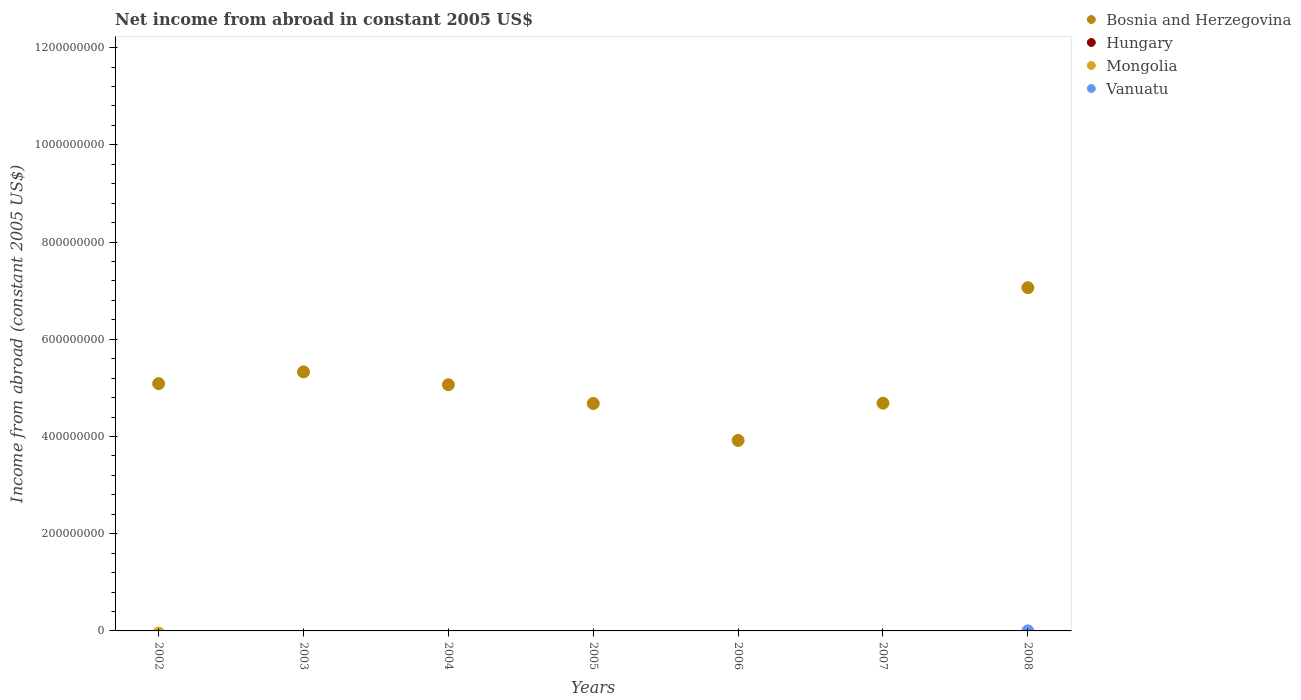How many different coloured dotlines are there?
Your response must be concise. 2. What is the net income from abroad in Mongolia in 2005?
Offer a terse response. 0. Across all years, what is the maximum net income from abroad in Bosnia and Herzegovina?
Offer a very short reply. 7.06e+08. In which year was the net income from abroad in Bosnia and Herzegovina maximum?
Give a very brief answer. 2008. What is the total net income from abroad in Mongolia in the graph?
Keep it short and to the point. 0. What is the difference between the net income from abroad in Bosnia and Herzegovina in 2003 and that in 2006?
Give a very brief answer. 1.41e+08. What is the difference between the net income from abroad in Mongolia in 2002 and the net income from abroad in Bosnia and Herzegovina in 2008?
Your answer should be very brief. -7.06e+08. What is the average net income from abroad in Bosnia and Herzegovina per year?
Keep it short and to the point. 5.12e+08. In how many years, is the net income from abroad in Vanuatu greater than 1040000000 US$?
Provide a succinct answer. 0. What is the ratio of the net income from abroad in Bosnia and Herzegovina in 2005 to that in 2007?
Provide a succinct answer. 1. Is the net income from abroad in Bosnia and Herzegovina in 2004 less than that in 2005?
Give a very brief answer. No. What is the difference between the highest and the second highest net income from abroad in Bosnia and Herzegovina?
Keep it short and to the point. 1.73e+08. What is the difference between the highest and the lowest net income from abroad in Vanuatu?
Your answer should be very brief. 9.87e+04. Is the sum of the net income from abroad in Bosnia and Herzegovina in 2003 and 2005 greater than the maximum net income from abroad in Vanuatu across all years?
Ensure brevity in your answer.  Yes. Is it the case that in every year, the sum of the net income from abroad in Vanuatu and net income from abroad in Bosnia and Herzegovina  is greater than the sum of net income from abroad in Hungary and net income from abroad in Mongolia?
Offer a very short reply. Yes. Is it the case that in every year, the sum of the net income from abroad in Mongolia and net income from abroad in Bosnia and Herzegovina  is greater than the net income from abroad in Vanuatu?
Provide a short and direct response. Yes. Does the net income from abroad in Hungary monotonically increase over the years?
Your response must be concise. No. Is the net income from abroad in Hungary strictly less than the net income from abroad in Vanuatu over the years?
Provide a succinct answer. Yes. What is the difference between two consecutive major ticks on the Y-axis?
Make the answer very short. 2.00e+08. Are the values on the major ticks of Y-axis written in scientific E-notation?
Offer a terse response. No. Does the graph contain any zero values?
Give a very brief answer. Yes. How many legend labels are there?
Your response must be concise. 4. What is the title of the graph?
Offer a very short reply. Net income from abroad in constant 2005 US$. Does "Malta" appear as one of the legend labels in the graph?
Give a very brief answer. No. What is the label or title of the X-axis?
Ensure brevity in your answer.  Years. What is the label or title of the Y-axis?
Provide a short and direct response. Income from abroad (constant 2005 US$). What is the Income from abroad (constant 2005 US$) of Bosnia and Herzegovina in 2002?
Offer a very short reply. 5.09e+08. What is the Income from abroad (constant 2005 US$) of Hungary in 2002?
Your response must be concise. 0. What is the Income from abroad (constant 2005 US$) of Bosnia and Herzegovina in 2003?
Ensure brevity in your answer.  5.33e+08. What is the Income from abroad (constant 2005 US$) in Hungary in 2003?
Your answer should be compact. 0. What is the Income from abroad (constant 2005 US$) of Vanuatu in 2003?
Provide a short and direct response. 0. What is the Income from abroad (constant 2005 US$) in Bosnia and Herzegovina in 2004?
Ensure brevity in your answer.  5.06e+08. What is the Income from abroad (constant 2005 US$) of Bosnia and Herzegovina in 2005?
Your answer should be very brief. 4.68e+08. What is the Income from abroad (constant 2005 US$) in Hungary in 2005?
Your answer should be compact. 0. What is the Income from abroad (constant 2005 US$) of Bosnia and Herzegovina in 2006?
Keep it short and to the point. 3.92e+08. What is the Income from abroad (constant 2005 US$) of Hungary in 2006?
Offer a very short reply. 0. What is the Income from abroad (constant 2005 US$) of Vanuatu in 2006?
Provide a succinct answer. 0. What is the Income from abroad (constant 2005 US$) in Bosnia and Herzegovina in 2007?
Your answer should be very brief. 4.69e+08. What is the Income from abroad (constant 2005 US$) in Vanuatu in 2007?
Provide a succinct answer. 0. What is the Income from abroad (constant 2005 US$) in Bosnia and Herzegovina in 2008?
Ensure brevity in your answer.  7.06e+08. What is the Income from abroad (constant 2005 US$) of Vanuatu in 2008?
Keep it short and to the point. 9.87e+04. Across all years, what is the maximum Income from abroad (constant 2005 US$) in Bosnia and Herzegovina?
Ensure brevity in your answer.  7.06e+08. Across all years, what is the maximum Income from abroad (constant 2005 US$) of Vanuatu?
Your answer should be very brief. 9.87e+04. Across all years, what is the minimum Income from abroad (constant 2005 US$) in Bosnia and Herzegovina?
Keep it short and to the point. 3.92e+08. Across all years, what is the minimum Income from abroad (constant 2005 US$) in Vanuatu?
Make the answer very short. 0. What is the total Income from abroad (constant 2005 US$) of Bosnia and Herzegovina in the graph?
Your answer should be compact. 3.58e+09. What is the total Income from abroad (constant 2005 US$) of Hungary in the graph?
Your answer should be compact. 0. What is the total Income from abroad (constant 2005 US$) in Vanuatu in the graph?
Offer a terse response. 9.87e+04. What is the difference between the Income from abroad (constant 2005 US$) of Bosnia and Herzegovina in 2002 and that in 2003?
Your answer should be very brief. -2.42e+07. What is the difference between the Income from abroad (constant 2005 US$) in Bosnia and Herzegovina in 2002 and that in 2004?
Make the answer very short. 2.28e+06. What is the difference between the Income from abroad (constant 2005 US$) in Bosnia and Herzegovina in 2002 and that in 2005?
Your answer should be very brief. 4.08e+07. What is the difference between the Income from abroad (constant 2005 US$) in Bosnia and Herzegovina in 2002 and that in 2006?
Offer a very short reply. 1.17e+08. What is the difference between the Income from abroad (constant 2005 US$) in Bosnia and Herzegovina in 2002 and that in 2007?
Ensure brevity in your answer.  4.02e+07. What is the difference between the Income from abroad (constant 2005 US$) of Bosnia and Herzegovina in 2002 and that in 2008?
Ensure brevity in your answer.  -1.97e+08. What is the difference between the Income from abroad (constant 2005 US$) in Bosnia and Herzegovina in 2003 and that in 2004?
Give a very brief answer. 2.64e+07. What is the difference between the Income from abroad (constant 2005 US$) of Bosnia and Herzegovina in 2003 and that in 2005?
Make the answer very short. 6.49e+07. What is the difference between the Income from abroad (constant 2005 US$) in Bosnia and Herzegovina in 2003 and that in 2006?
Provide a succinct answer. 1.41e+08. What is the difference between the Income from abroad (constant 2005 US$) of Bosnia and Herzegovina in 2003 and that in 2007?
Your answer should be very brief. 6.43e+07. What is the difference between the Income from abroad (constant 2005 US$) in Bosnia and Herzegovina in 2003 and that in 2008?
Ensure brevity in your answer.  -1.73e+08. What is the difference between the Income from abroad (constant 2005 US$) in Bosnia and Herzegovina in 2004 and that in 2005?
Provide a short and direct response. 3.85e+07. What is the difference between the Income from abroad (constant 2005 US$) of Bosnia and Herzegovina in 2004 and that in 2006?
Ensure brevity in your answer.  1.15e+08. What is the difference between the Income from abroad (constant 2005 US$) of Bosnia and Herzegovina in 2004 and that in 2007?
Offer a terse response. 3.79e+07. What is the difference between the Income from abroad (constant 2005 US$) in Bosnia and Herzegovina in 2004 and that in 2008?
Give a very brief answer. -2.00e+08. What is the difference between the Income from abroad (constant 2005 US$) in Bosnia and Herzegovina in 2005 and that in 2006?
Your answer should be very brief. 7.61e+07. What is the difference between the Income from abroad (constant 2005 US$) of Bosnia and Herzegovina in 2005 and that in 2007?
Your answer should be very brief. -5.87e+05. What is the difference between the Income from abroad (constant 2005 US$) in Bosnia and Herzegovina in 2005 and that in 2008?
Offer a terse response. -2.38e+08. What is the difference between the Income from abroad (constant 2005 US$) of Bosnia and Herzegovina in 2006 and that in 2007?
Ensure brevity in your answer.  -7.67e+07. What is the difference between the Income from abroad (constant 2005 US$) of Bosnia and Herzegovina in 2006 and that in 2008?
Provide a short and direct response. -3.14e+08. What is the difference between the Income from abroad (constant 2005 US$) in Bosnia and Herzegovina in 2007 and that in 2008?
Your response must be concise. -2.38e+08. What is the difference between the Income from abroad (constant 2005 US$) in Bosnia and Herzegovina in 2002 and the Income from abroad (constant 2005 US$) in Vanuatu in 2008?
Keep it short and to the point. 5.09e+08. What is the difference between the Income from abroad (constant 2005 US$) in Bosnia and Herzegovina in 2003 and the Income from abroad (constant 2005 US$) in Vanuatu in 2008?
Provide a short and direct response. 5.33e+08. What is the difference between the Income from abroad (constant 2005 US$) of Bosnia and Herzegovina in 2004 and the Income from abroad (constant 2005 US$) of Vanuatu in 2008?
Offer a terse response. 5.06e+08. What is the difference between the Income from abroad (constant 2005 US$) in Bosnia and Herzegovina in 2005 and the Income from abroad (constant 2005 US$) in Vanuatu in 2008?
Provide a succinct answer. 4.68e+08. What is the difference between the Income from abroad (constant 2005 US$) of Bosnia and Herzegovina in 2006 and the Income from abroad (constant 2005 US$) of Vanuatu in 2008?
Make the answer very short. 3.92e+08. What is the difference between the Income from abroad (constant 2005 US$) in Bosnia and Herzegovina in 2007 and the Income from abroad (constant 2005 US$) in Vanuatu in 2008?
Your response must be concise. 4.68e+08. What is the average Income from abroad (constant 2005 US$) in Bosnia and Herzegovina per year?
Offer a very short reply. 5.12e+08. What is the average Income from abroad (constant 2005 US$) in Hungary per year?
Give a very brief answer. 0. What is the average Income from abroad (constant 2005 US$) of Vanuatu per year?
Your answer should be compact. 1.41e+04. In the year 2008, what is the difference between the Income from abroad (constant 2005 US$) of Bosnia and Herzegovina and Income from abroad (constant 2005 US$) of Vanuatu?
Give a very brief answer. 7.06e+08. What is the ratio of the Income from abroad (constant 2005 US$) of Bosnia and Herzegovina in 2002 to that in 2003?
Offer a terse response. 0.95. What is the ratio of the Income from abroad (constant 2005 US$) in Bosnia and Herzegovina in 2002 to that in 2004?
Your response must be concise. 1. What is the ratio of the Income from abroad (constant 2005 US$) of Bosnia and Herzegovina in 2002 to that in 2005?
Offer a very short reply. 1.09. What is the ratio of the Income from abroad (constant 2005 US$) in Bosnia and Herzegovina in 2002 to that in 2006?
Provide a short and direct response. 1.3. What is the ratio of the Income from abroad (constant 2005 US$) of Bosnia and Herzegovina in 2002 to that in 2007?
Provide a succinct answer. 1.09. What is the ratio of the Income from abroad (constant 2005 US$) in Bosnia and Herzegovina in 2002 to that in 2008?
Your answer should be compact. 0.72. What is the ratio of the Income from abroad (constant 2005 US$) of Bosnia and Herzegovina in 2003 to that in 2004?
Keep it short and to the point. 1.05. What is the ratio of the Income from abroad (constant 2005 US$) of Bosnia and Herzegovina in 2003 to that in 2005?
Keep it short and to the point. 1.14. What is the ratio of the Income from abroad (constant 2005 US$) of Bosnia and Herzegovina in 2003 to that in 2006?
Your answer should be compact. 1.36. What is the ratio of the Income from abroad (constant 2005 US$) of Bosnia and Herzegovina in 2003 to that in 2007?
Give a very brief answer. 1.14. What is the ratio of the Income from abroad (constant 2005 US$) of Bosnia and Herzegovina in 2003 to that in 2008?
Your response must be concise. 0.75. What is the ratio of the Income from abroad (constant 2005 US$) of Bosnia and Herzegovina in 2004 to that in 2005?
Offer a very short reply. 1.08. What is the ratio of the Income from abroad (constant 2005 US$) in Bosnia and Herzegovina in 2004 to that in 2006?
Your response must be concise. 1.29. What is the ratio of the Income from abroad (constant 2005 US$) of Bosnia and Herzegovina in 2004 to that in 2007?
Your response must be concise. 1.08. What is the ratio of the Income from abroad (constant 2005 US$) of Bosnia and Herzegovina in 2004 to that in 2008?
Provide a succinct answer. 0.72. What is the ratio of the Income from abroad (constant 2005 US$) of Bosnia and Herzegovina in 2005 to that in 2006?
Your answer should be very brief. 1.19. What is the ratio of the Income from abroad (constant 2005 US$) in Bosnia and Herzegovina in 2005 to that in 2007?
Your answer should be very brief. 1. What is the ratio of the Income from abroad (constant 2005 US$) of Bosnia and Herzegovina in 2005 to that in 2008?
Keep it short and to the point. 0.66. What is the ratio of the Income from abroad (constant 2005 US$) of Bosnia and Herzegovina in 2006 to that in 2007?
Your answer should be very brief. 0.84. What is the ratio of the Income from abroad (constant 2005 US$) in Bosnia and Herzegovina in 2006 to that in 2008?
Provide a succinct answer. 0.55. What is the ratio of the Income from abroad (constant 2005 US$) in Bosnia and Herzegovina in 2007 to that in 2008?
Your response must be concise. 0.66. What is the difference between the highest and the second highest Income from abroad (constant 2005 US$) of Bosnia and Herzegovina?
Provide a short and direct response. 1.73e+08. What is the difference between the highest and the lowest Income from abroad (constant 2005 US$) of Bosnia and Herzegovina?
Offer a terse response. 3.14e+08. What is the difference between the highest and the lowest Income from abroad (constant 2005 US$) in Vanuatu?
Provide a succinct answer. 9.87e+04. 